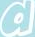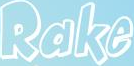Transcribe the words shown in these images in order, separated by a semicolon. a; Rake 